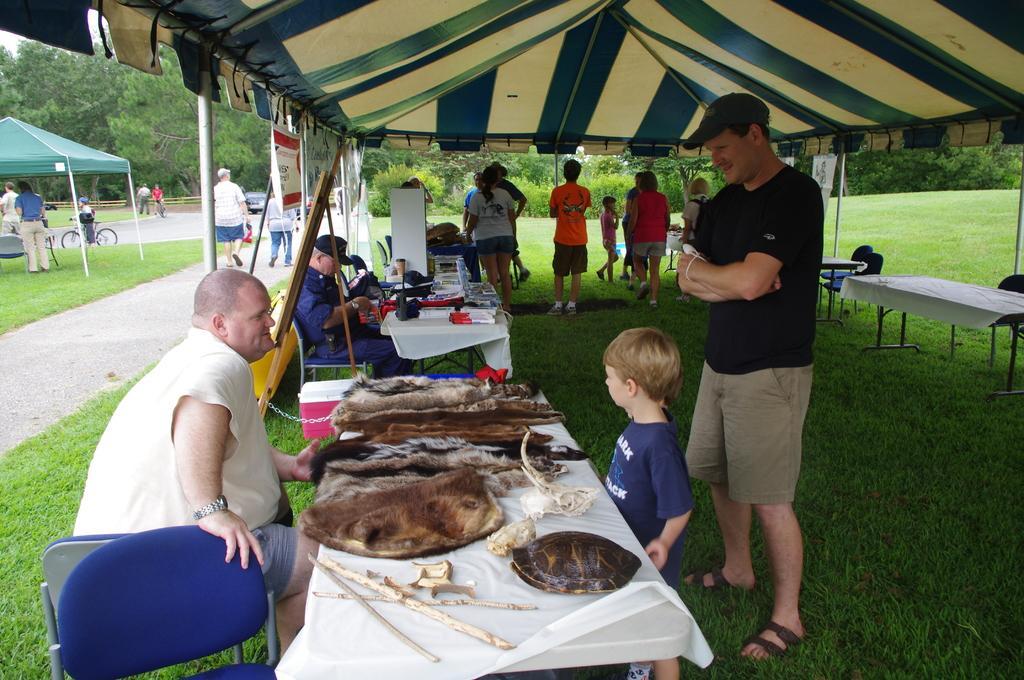In one or two sentences, can you explain what this image depicts? Here we can see a group of people sitting on chairs with food on the table present in front of them and there are other people standing here and there under the tent present and at the back we can see trees and plants 